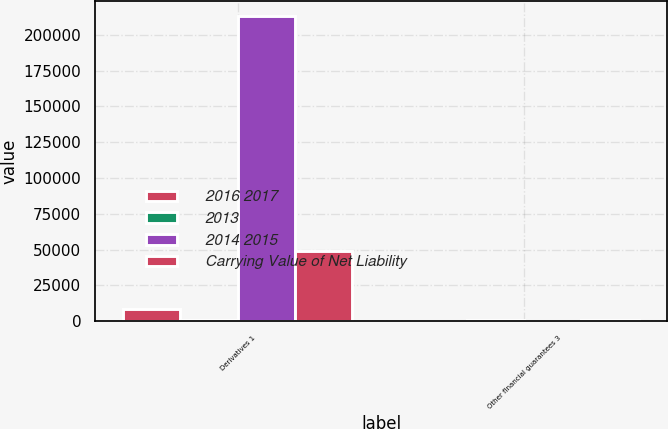Convert chart. <chart><loc_0><loc_0><loc_500><loc_500><stacked_bar_chart><ecel><fcel>Derivatives 1<fcel>Other financial guarantees 3<nl><fcel>2016 2017<fcel>8581<fcel>152<nl><fcel>2013<fcel>1195<fcel>904<nl><fcel>2014 2015<fcel>213012<fcel>442<nl><fcel>Carrying Value of Net Liability<fcel>49413<fcel>1195<nl></chart> 